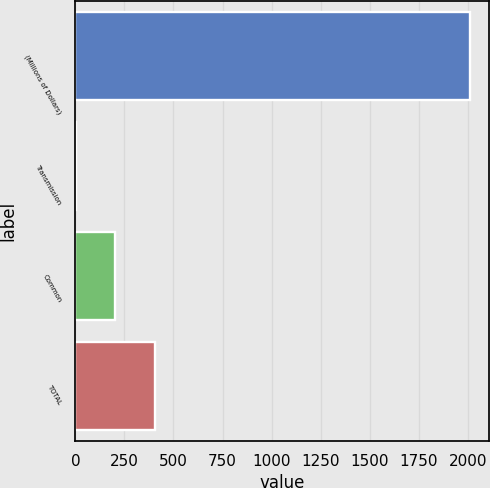<chart> <loc_0><loc_0><loc_500><loc_500><bar_chart><fcel>(Millions of Dollars)<fcel>Transmission<fcel>Common<fcel>TOTAL<nl><fcel>2009<fcel>3<fcel>203.6<fcel>404.2<nl></chart> 